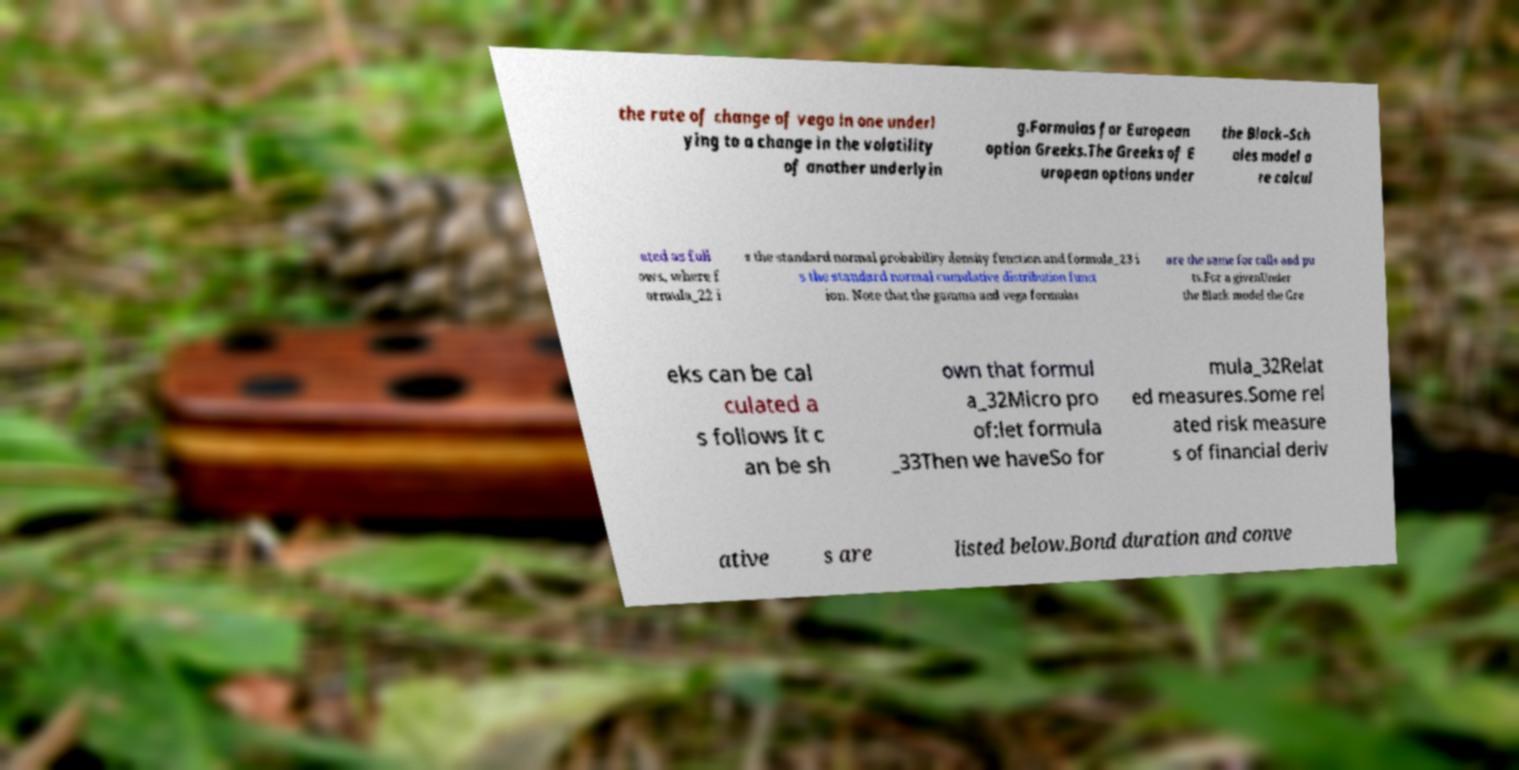Could you extract and type out the text from this image? the rate of change of vega in one underl ying to a change in the volatility of another underlyin g.Formulas for European option Greeks.The Greeks of E uropean options under the Black–Sch oles model a re calcul ated as foll ows, where f ormula_22 i s the standard normal probability density function and formula_23 i s the standard normal cumulative distribution funct ion. Note that the gamma and vega formulas are the same for calls and pu ts.For a givenUnder the Black model the Gre eks can be cal culated a s follows It c an be sh own that formul a_32Micro pro of:let formula _33Then we haveSo for mula_32Relat ed measures.Some rel ated risk measure s of financial deriv ative s are listed below.Bond duration and conve 